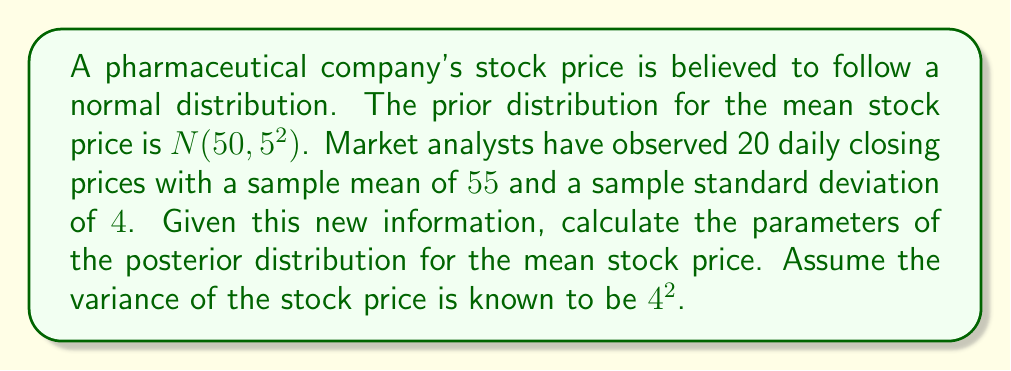Solve this math problem. To solve this problem, we'll use Bayesian inference for a normal distribution with known variance. We'll follow these steps:

1) First, let's define our variables:
   $\mu$ = true mean stock price
   $\sigma^2$ = known variance of stock price = $4^2 = 16$
   $\mu_0$ = prior mean = 50
   $\sigma_0^2$ = prior variance = $5^2 = 25$
   $\bar{x}$ = sample mean = 55
   $n$ = sample size = 20

2) The formula for the posterior mean ($\mu_n$) is:

   $$\mu_n = \frac{\frac{\mu_0}{\sigma_0^2} + \frac{n\bar{x}}{\sigma^2}}{\frac{1}{\sigma_0^2} + \frac{n}{\sigma^2}}$$

3) The formula for the posterior variance ($\sigma_n^2$) is:

   $$\sigma_n^2 = \frac{1}{\frac{1}{\sigma_0^2} + \frac{n}{\sigma^2}}$$

4) Let's calculate the posterior variance first:
   
   $$\sigma_n^2 = \frac{1}{\frac{1}{25} + \frac{20}{16}} = \frac{1}{0.04 + 1.25} = \frac{1}{1.29} \approx 0.7752$$

5) Now, let's calculate the posterior mean:

   $$\mu_n = \frac{\frac{50}{25} + \frac{20 * 55}{16}}{\frac{1}{25} + \frac{20}{16}} = \frac{2 + 68.75}{1.29} = \frac{70.75}{1.29} \approx 54.8450$$

6) Therefore, the posterior distribution is $N(54.8450, 0.7752)$.
Answer: The posterior distribution for the mean stock price is $N(54.8450, 0.7752)$. 